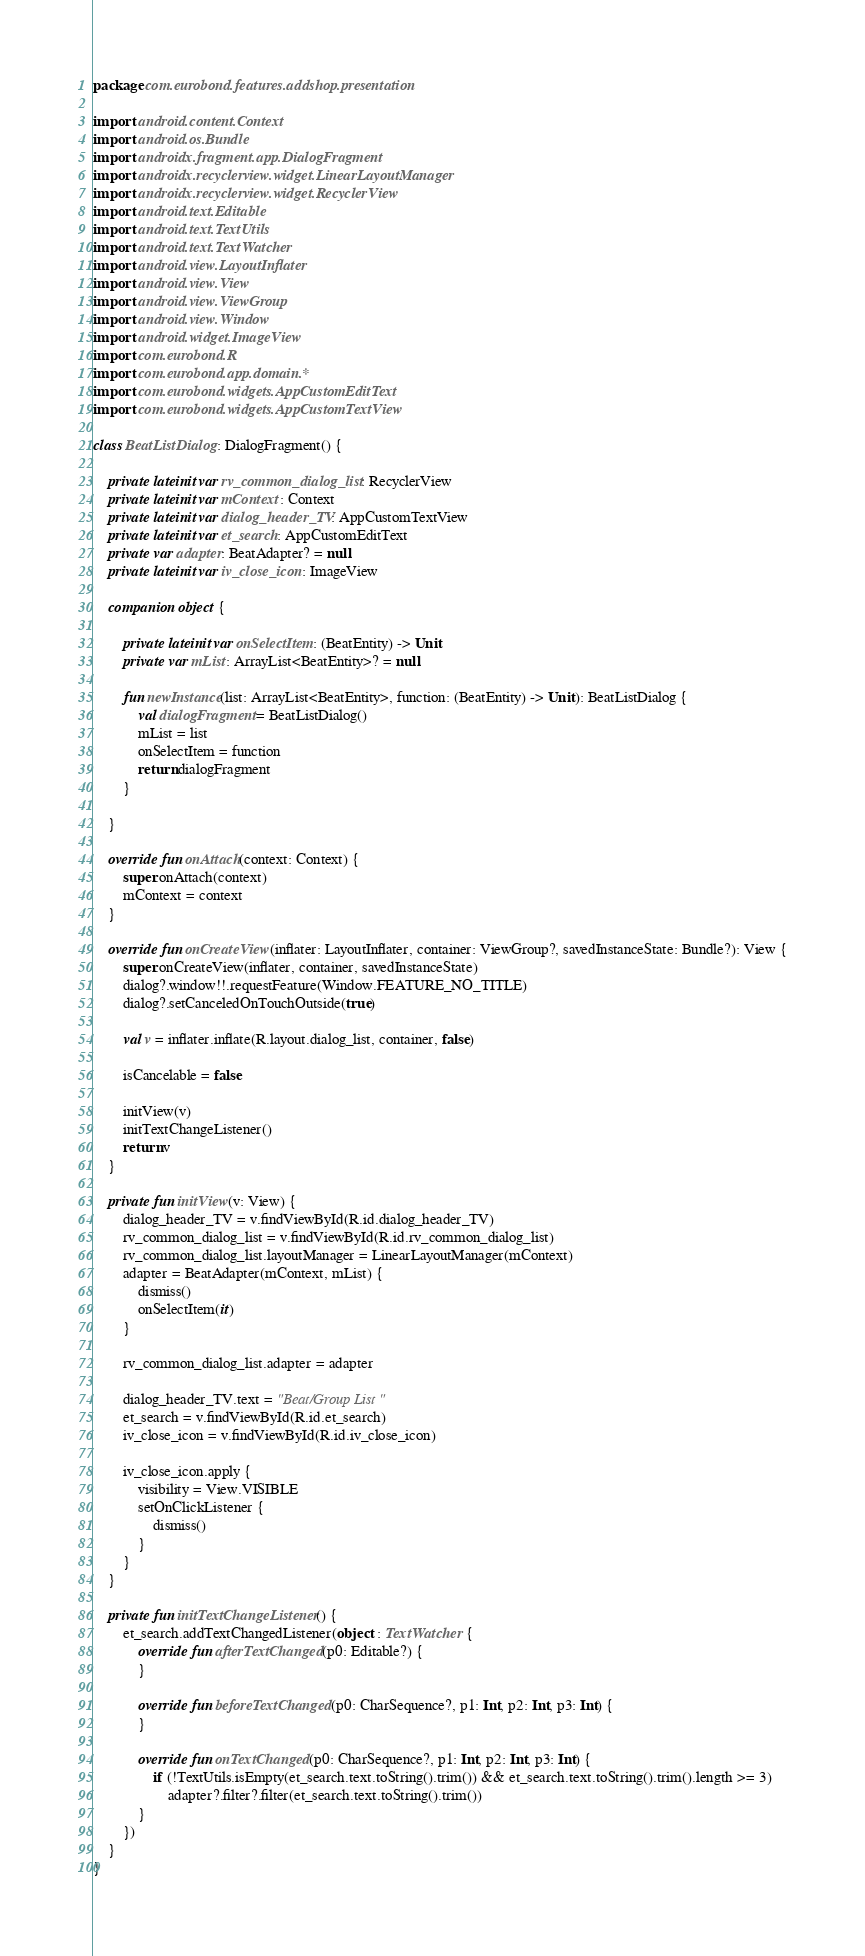<code> <loc_0><loc_0><loc_500><loc_500><_Kotlin_>package com.eurobond.features.addshop.presentation

import android.content.Context
import android.os.Bundle
import androidx.fragment.app.DialogFragment
import androidx.recyclerview.widget.LinearLayoutManager
import androidx.recyclerview.widget.RecyclerView
import android.text.Editable
import android.text.TextUtils
import android.text.TextWatcher
import android.view.LayoutInflater
import android.view.View
import android.view.ViewGroup
import android.view.Window
import android.widget.ImageView
import com.eurobond.R
import com.eurobond.app.domain.*
import com.eurobond.widgets.AppCustomEditText
import com.eurobond.widgets.AppCustomTextView

class BeatListDialog : DialogFragment() {

    private lateinit var rv_common_dialog_list: RecyclerView
    private lateinit var mContext: Context
    private lateinit var dialog_header_TV: AppCustomTextView
    private lateinit var et_search: AppCustomEditText
    private var adapter: BeatAdapter? = null
    private lateinit var iv_close_icon: ImageView

    companion object {

        private lateinit var onSelectItem: (BeatEntity) -> Unit
        private var mList: ArrayList<BeatEntity>? = null

        fun newInstance(list: ArrayList<BeatEntity>, function: (BeatEntity) -> Unit): BeatListDialog {
            val dialogFragment = BeatListDialog()
            mList = list
            onSelectItem = function
            return dialogFragment
        }

    }

    override fun onAttach(context: Context) {
        super.onAttach(context)
        mContext = context
    }

    override fun onCreateView(inflater: LayoutInflater, container: ViewGroup?, savedInstanceState: Bundle?): View {
        super.onCreateView(inflater, container, savedInstanceState)
        dialog?.window!!.requestFeature(Window.FEATURE_NO_TITLE)
        dialog?.setCanceledOnTouchOutside(true)

        val v = inflater.inflate(R.layout.dialog_list, container, false)

        isCancelable = false

        initView(v)
        initTextChangeListener()
        return v
    }

    private fun initView(v: View) {
        dialog_header_TV = v.findViewById(R.id.dialog_header_TV)
        rv_common_dialog_list = v.findViewById(R.id.rv_common_dialog_list)
        rv_common_dialog_list.layoutManager = LinearLayoutManager(mContext)
        adapter = BeatAdapter(mContext, mList) {
            dismiss()
            onSelectItem(it)
        }

        rv_common_dialog_list.adapter = adapter

        dialog_header_TV.text = "Beat/Group List"
        et_search = v.findViewById(R.id.et_search)
        iv_close_icon = v.findViewById(R.id.iv_close_icon)

        iv_close_icon.apply {
            visibility = View.VISIBLE
            setOnClickListener {
                dismiss()
            }
        }
    }

    private fun initTextChangeListener() {
        et_search.addTextChangedListener(object : TextWatcher {
            override fun afterTextChanged(p0: Editable?) {
            }

            override fun beforeTextChanged(p0: CharSequence?, p1: Int, p2: Int, p3: Int) {
            }

            override fun onTextChanged(p0: CharSequence?, p1: Int, p2: Int, p3: Int) {
                if (!TextUtils.isEmpty(et_search.text.toString().trim()) && et_search.text.toString().trim().length >= 3)
                    adapter?.filter?.filter(et_search.text.toString().trim())
            }
        })
    }
}</code> 